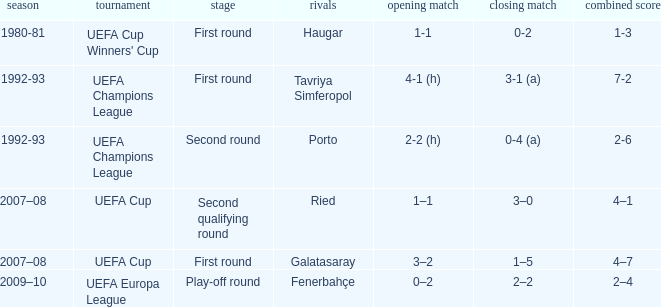 what's the aggregate where 1st leg is 3–2 4–7. 